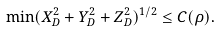Convert formula to latex. <formula><loc_0><loc_0><loc_500><loc_500>\min ( X _ { D } ^ { 2 } + Y _ { D } ^ { 2 } + Z _ { D } ^ { 2 } ) ^ { 1 / 2 } \leq { C ( } \rho { ) . }</formula> 